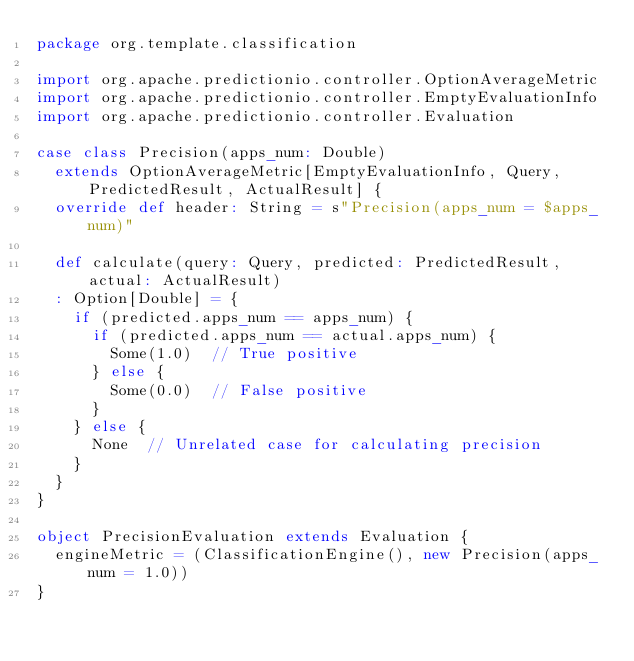Convert code to text. <code><loc_0><loc_0><loc_500><loc_500><_Scala_>package org.template.classification

import org.apache.predictionio.controller.OptionAverageMetric
import org.apache.predictionio.controller.EmptyEvaluationInfo
import org.apache.predictionio.controller.Evaluation

case class Precision(apps_num: Double)
  extends OptionAverageMetric[EmptyEvaluationInfo, Query, PredictedResult, ActualResult] {
  override def header: String = s"Precision(apps_num = $apps_num)"

  def calculate(query: Query, predicted: PredictedResult, actual: ActualResult)
  : Option[Double] = {
    if (predicted.apps_num == apps_num) {
      if (predicted.apps_num == actual.apps_num) {
        Some(1.0)  // True positive
      } else {
        Some(0.0)  // False positive
      }
    } else {
      None  // Unrelated case for calculating precision
    }
  }
}

object PrecisionEvaluation extends Evaluation {
  engineMetric = (ClassificationEngine(), new Precision(apps_num = 1.0))
}
</code> 